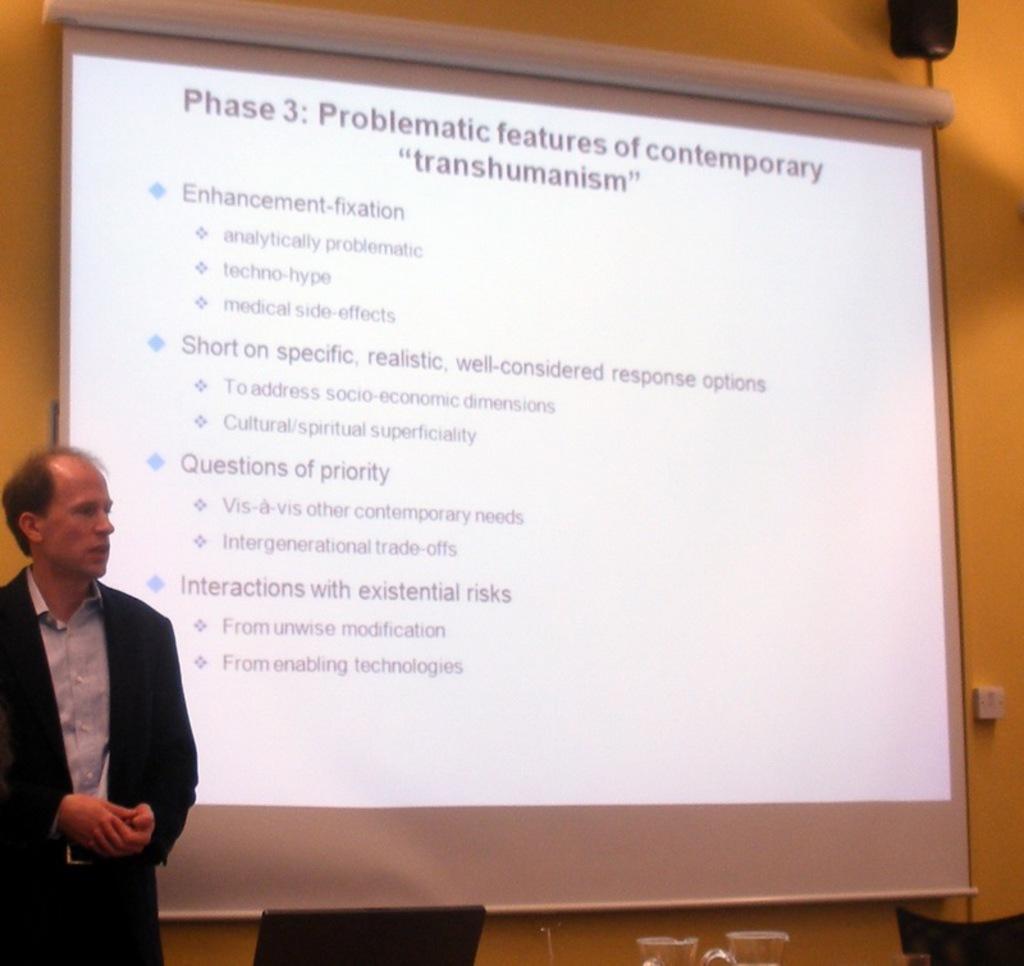Please provide a concise description of this image. The man on the left side is standing and I think he is trying to explain something. At the bottom, we see the chairs and the cups. In the middle of the picture, we see the projector screen with some text displayed on it. Behind that, we see a wall. In the right top, we see an object in black color. 